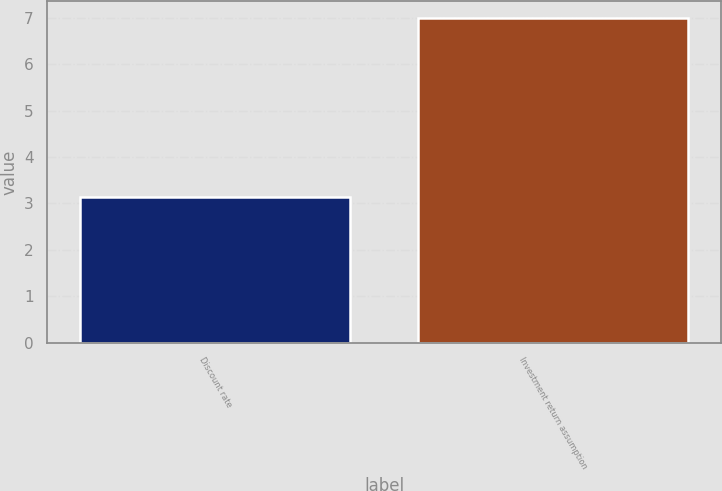Convert chart. <chart><loc_0><loc_0><loc_500><loc_500><bar_chart><fcel>Discount rate<fcel>Investment return assumption<nl><fcel>3.14<fcel>7<nl></chart> 